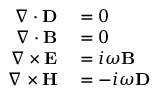<formula> <loc_0><loc_0><loc_500><loc_500>\begin{array} { r l } { \nabla \cdot D } & = 0 } \\ { \nabla \cdot B } & = 0 } \\ { \nabla \times E } & = i \omega B } \\ { \nabla \times H } & = - i \omega D } \end{array}</formula> 